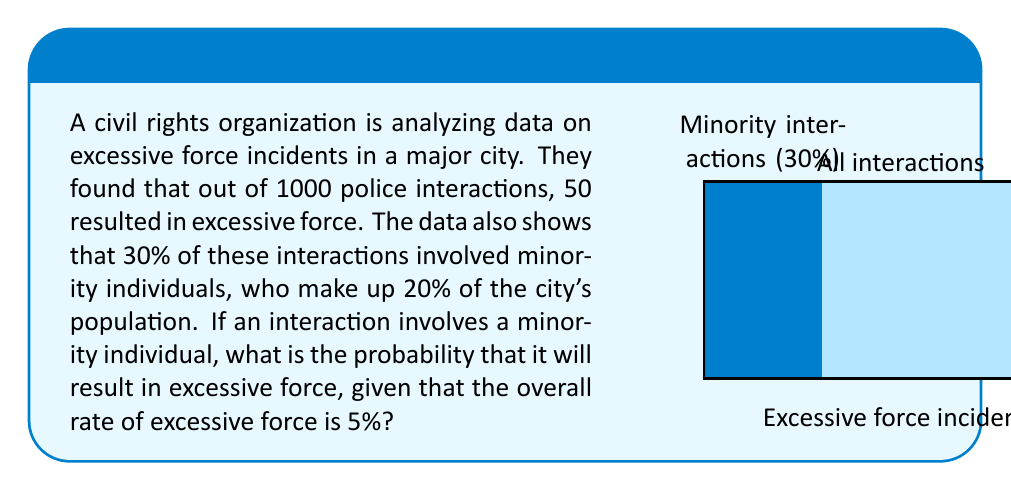Give your solution to this math problem. Let's approach this step-by-step using Bayes' theorem:

1) Let's define our events:
   A: Excessive force occurs
   B: Interaction involves a minority individual

2) We're given:
   P(A) = 0.05 (5% overall rate of excessive force)
   P(B) = 0.30 (30% of interactions involve minorities)
   P(B|population) = 0.20 (20% of population is minority)

3) We need to find P(A|B) using Bayes' theorem:

   $$P(A|B) = \frac{P(B|A) \cdot P(A)}{P(B)}$$

4) We know P(A) and P(B), but we need to find P(B|A).

5) To find P(B|A), let's use the given data:
   - Total excessive force incidents: 50
   - If minorities were involved in proportion to their population, we'd expect:
     50 * 0.20 = 10 incidents involving minorities
   - But if minorities are overrepresented in excessive force incidents, this number would be higher.
   - Let's say x is the number of excessive force incidents involving minorities.

6) We can set up an equation:
   $$\frac{x}{50} = \frac{0.30}{0.20} \cdot \frac{10}{50}$$
   This equation states that the proportion of excessive force incidents involving minorities (x/50) is equal to the ratio of their involvement in interactions (0.30/0.20) times their expected involvement based on population (10/50).

7) Solving for x:
   $$x = \frac{0.30}{0.20} \cdot 10 = 15$$

8) So, P(B|A) = 15/50 = 0.30

9) Now we can apply Bayes' theorem:
   $$P(A|B) = \frac{0.30 \cdot 0.05}{0.30} = 0.05$$
Answer: 0.05 or 5% 